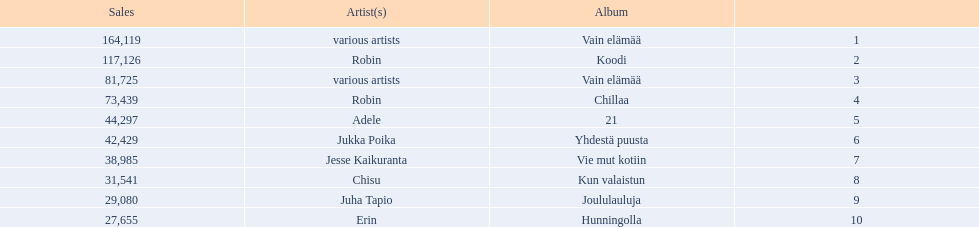What album is listed before 21? Chillaa. 